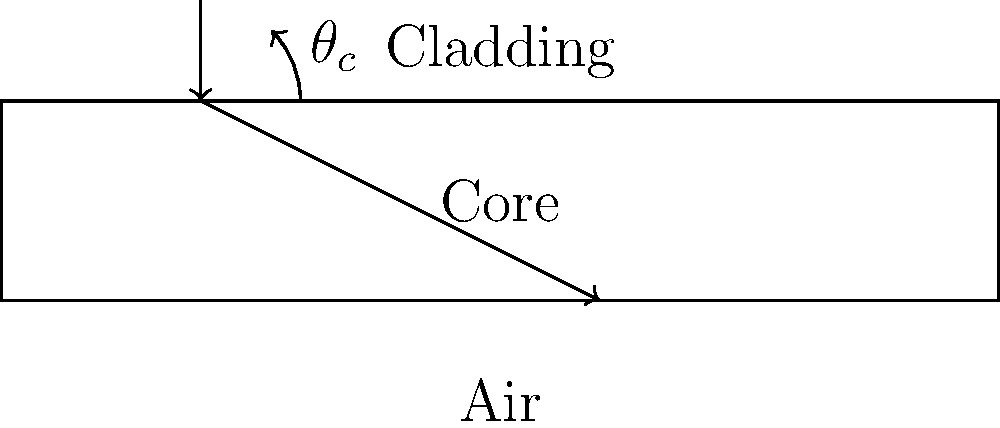In fiber optic communication, the principle of total internal reflection is crucial for efficient data transmission. Given the ray diagram of light propagation in an optical fiber, what is the relationship between the critical angle ($\theta_c$) and the refractive indices of the core ($n_1$) and cladding ($n_2$)? To understand the relationship between the critical angle and refractive indices in fiber optics, let's follow these steps:

1. Total internal reflection occurs when light travels from a medium with a higher refractive index to one with a lower refractive index.

2. In optical fibers, the core has a higher refractive index ($n_1$) than the cladding ($n_2$).

3. The critical angle ($\theta_c$) is the angle of incidence at which the angle of refraction becomes 90°.

4. At the critical angle, we can apply Snell's law:

   $n_1 \sin(\theta_c) = n_2 \sin(90°)$

5. Since $\sin(90°) = 1$, we can simplify the equation:

   $n_1 \sin(\theta_c) = n_2$

6. Solving for $\sin(\theta_c)$:

   $\sin(\theta_c) = \frac{n_2}{n_1}$

7. Taking the inverse sine (arcsin) of both sides:

   $\theta_c = \arcsin(\frac{n_2}{n_1})$

This equation gives us the relationship between the critical angle and the refractive indices of the core and cladding in an optical fiber.
Answer: $\theta_c = \arcsin(\frac{n_2}{n_1})$ 